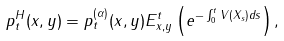Convert formula to latex. <formula><loc_0><loc_0><loc_500><loc_500>p _ { t } ^ { H } ( x , y ) = p _ { t } ^ { ( \alpha ) } ( x , y ) E _ { x , y } ^ { t } \left ( e ^ { - \int _ { 0 } ^ { t } V ( X _ { s } ) d s } \right ) ,</formula> 